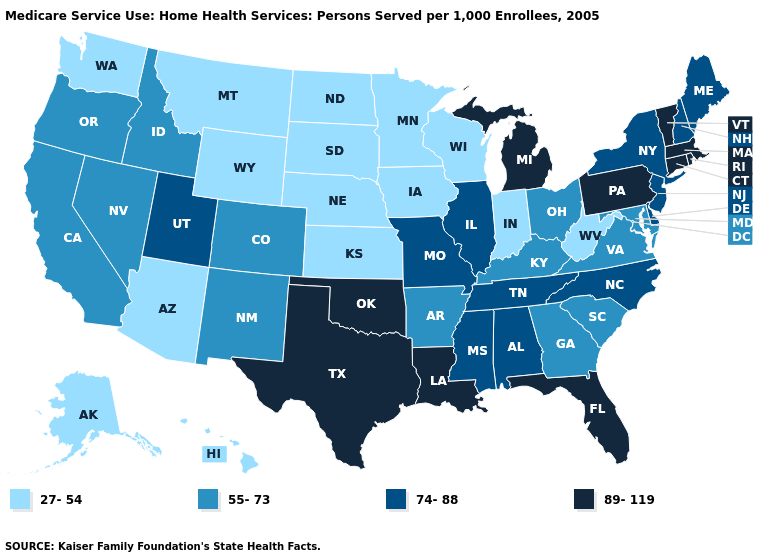Which states hav the highest value in the MidWest?
Be succinct. Michigan. What is the value of Kansas?
Be succinct. 27-54. Does Kentucky have the same value as Connecticut?
Write a very short answer. No. Name the states that have a value in the range 74-88?
Keep it brief. Alabama, Delaware, Illinois, Maine, Mississippi, Missouri, New Hampshire, New Jersey, New York, North Carolina, Tennessee, Utah. Among the states that border New Jersey , does Pennsylvania have the highest value?
Concise answer only. Yes. What is the value of New Jersey?
Answer briefly. 74-88. Name the states that have a value in the range 89-119?
Quick response, please. Connecticut, Florida, Louisiana, Massachusetts, Michigan, Oklahoma, Pennsylvania, Rhode Island, Texas, Vermont. Does Kansas have the lowest value in the USA?
Write a very short answer. Yes. What is the lowest value in the MidWest?
Give a very brief answer. 27-54. Which states have the lowest value in the USA?
Write a very short answer. Alaska, Arizona, Hawaii, Indiana, Iowa, Kansas, Minnesota, Montana, Nebraska, North Dakota, South Dakota, Washington, West Virginia, Wisconsin, Wyoming. Name the states that have a value in the range 27-54?
Keep it brief. Alaska, Arizona, Hawaii, Indiana, Iowa, Kansas, Minnesota, Montana, Nebraska, North Dakota, South Dakota, Washington, West Virginia, Wisconsin, Wyoming. Which states have the lowest value in the USA?
Answer briefly. Alaska, Arizona, Hawaii, Indiana, Iowa, Kansas, Minnesota, Montana, Nebraska, North Dakota, South Dakota, Washington, West Virginia, Wisconsin, Wyoming. Name the states that have a value in the range 89-119?
Keep it brief. Connecticut, Florida, Louisiana, Massachusetts, Michigan, Oklahoma, Pennsylvania, Rhode Island, Texas, Vermont. Does the first symbol in the legend represent the smallest category?
Concise answer only. Yes. Name the states that have a value in the range 27-54?
Answer briefly. Alaska, Arizona, Hawaii, Indiana, Iowa, Kansas, Minnesota, Montana, Nebraska, North Dakota, South Dakota, Washington, West Virginia, Wisconsin, Wyoming. 